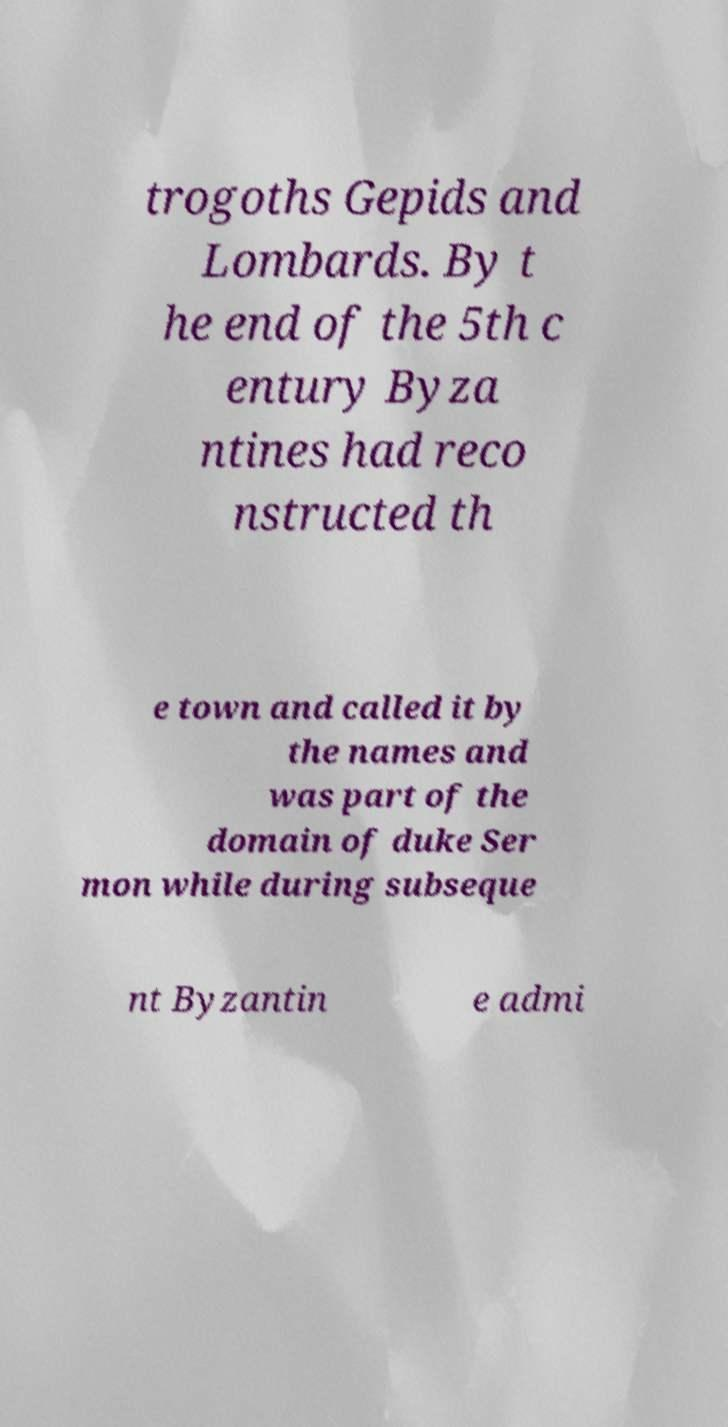Can you accurately transcribe the text from the provided image for me? trogoths Gepids and Lombards. By t he end of the 5th c entury Byza ntines had reco nstructed th e town and called it by the names and was part of the domain of duke Ser mon while during subseque nt Byzantin e admi 